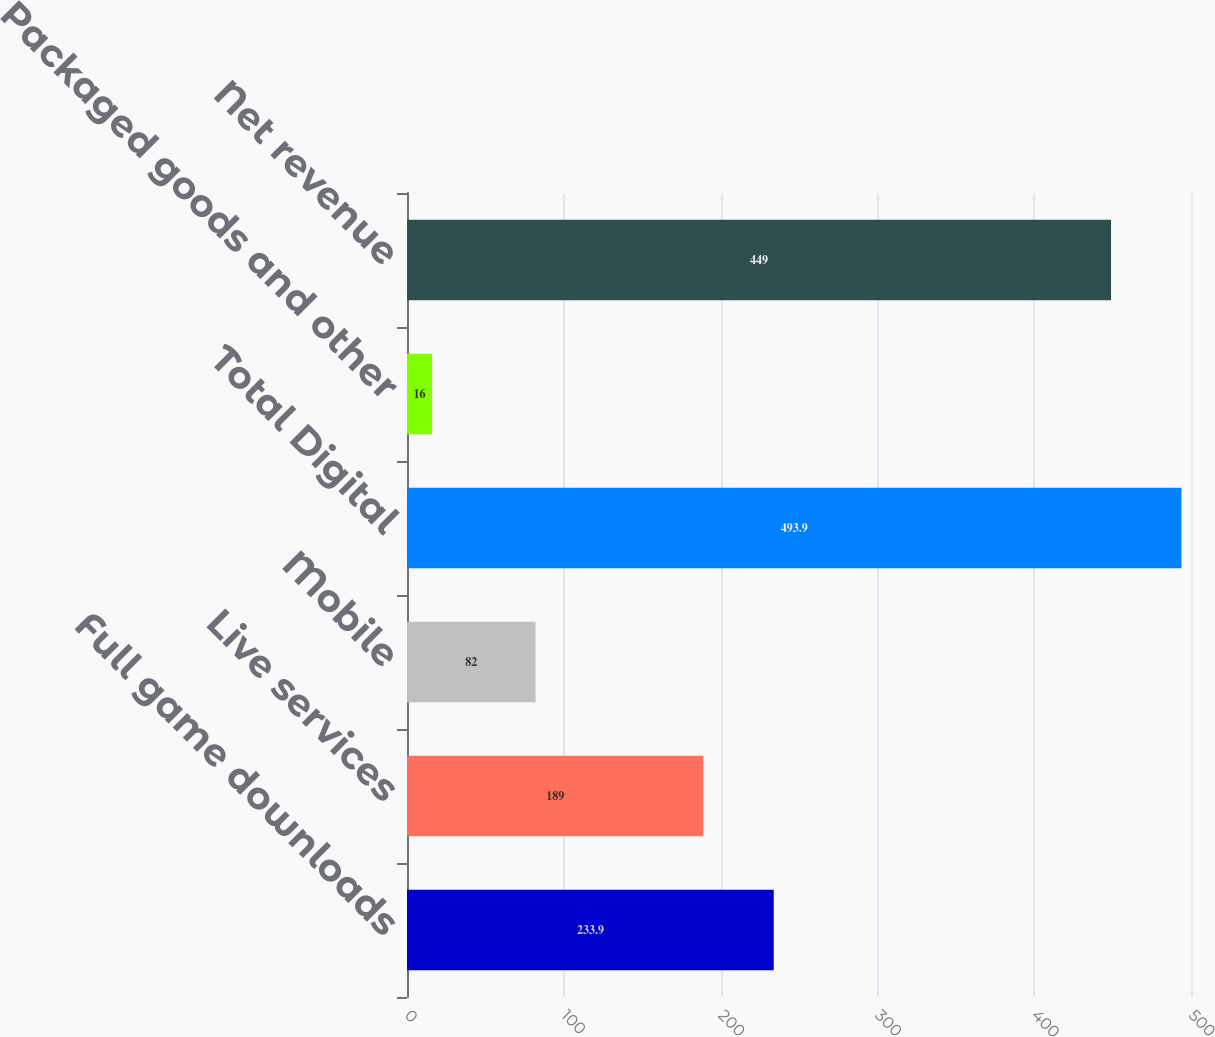Convert chart. <chart><loc_0><loc_0><loc_500><loc_500><bar_chart><fcel>Full game downloads<fcel>Live services<fcel>Mobile<fcel>Total Digital<fcel>Packaged goods and other<fcel>Net revenue<nl><fcel>233.9<fcel>189<fcel>82<fcel>493.9<fcel>16<fcel>449<nl></chart> 